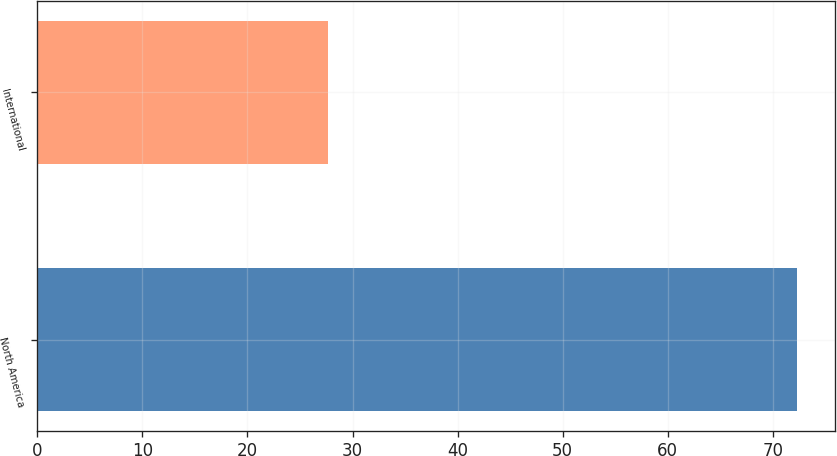<chart> <loc_0><loc_0><loc_500><loc_500><bar_chart><fcel>North America<fcel>International<nl><fcel>72.3<fcel>27.7<nl></chart> 